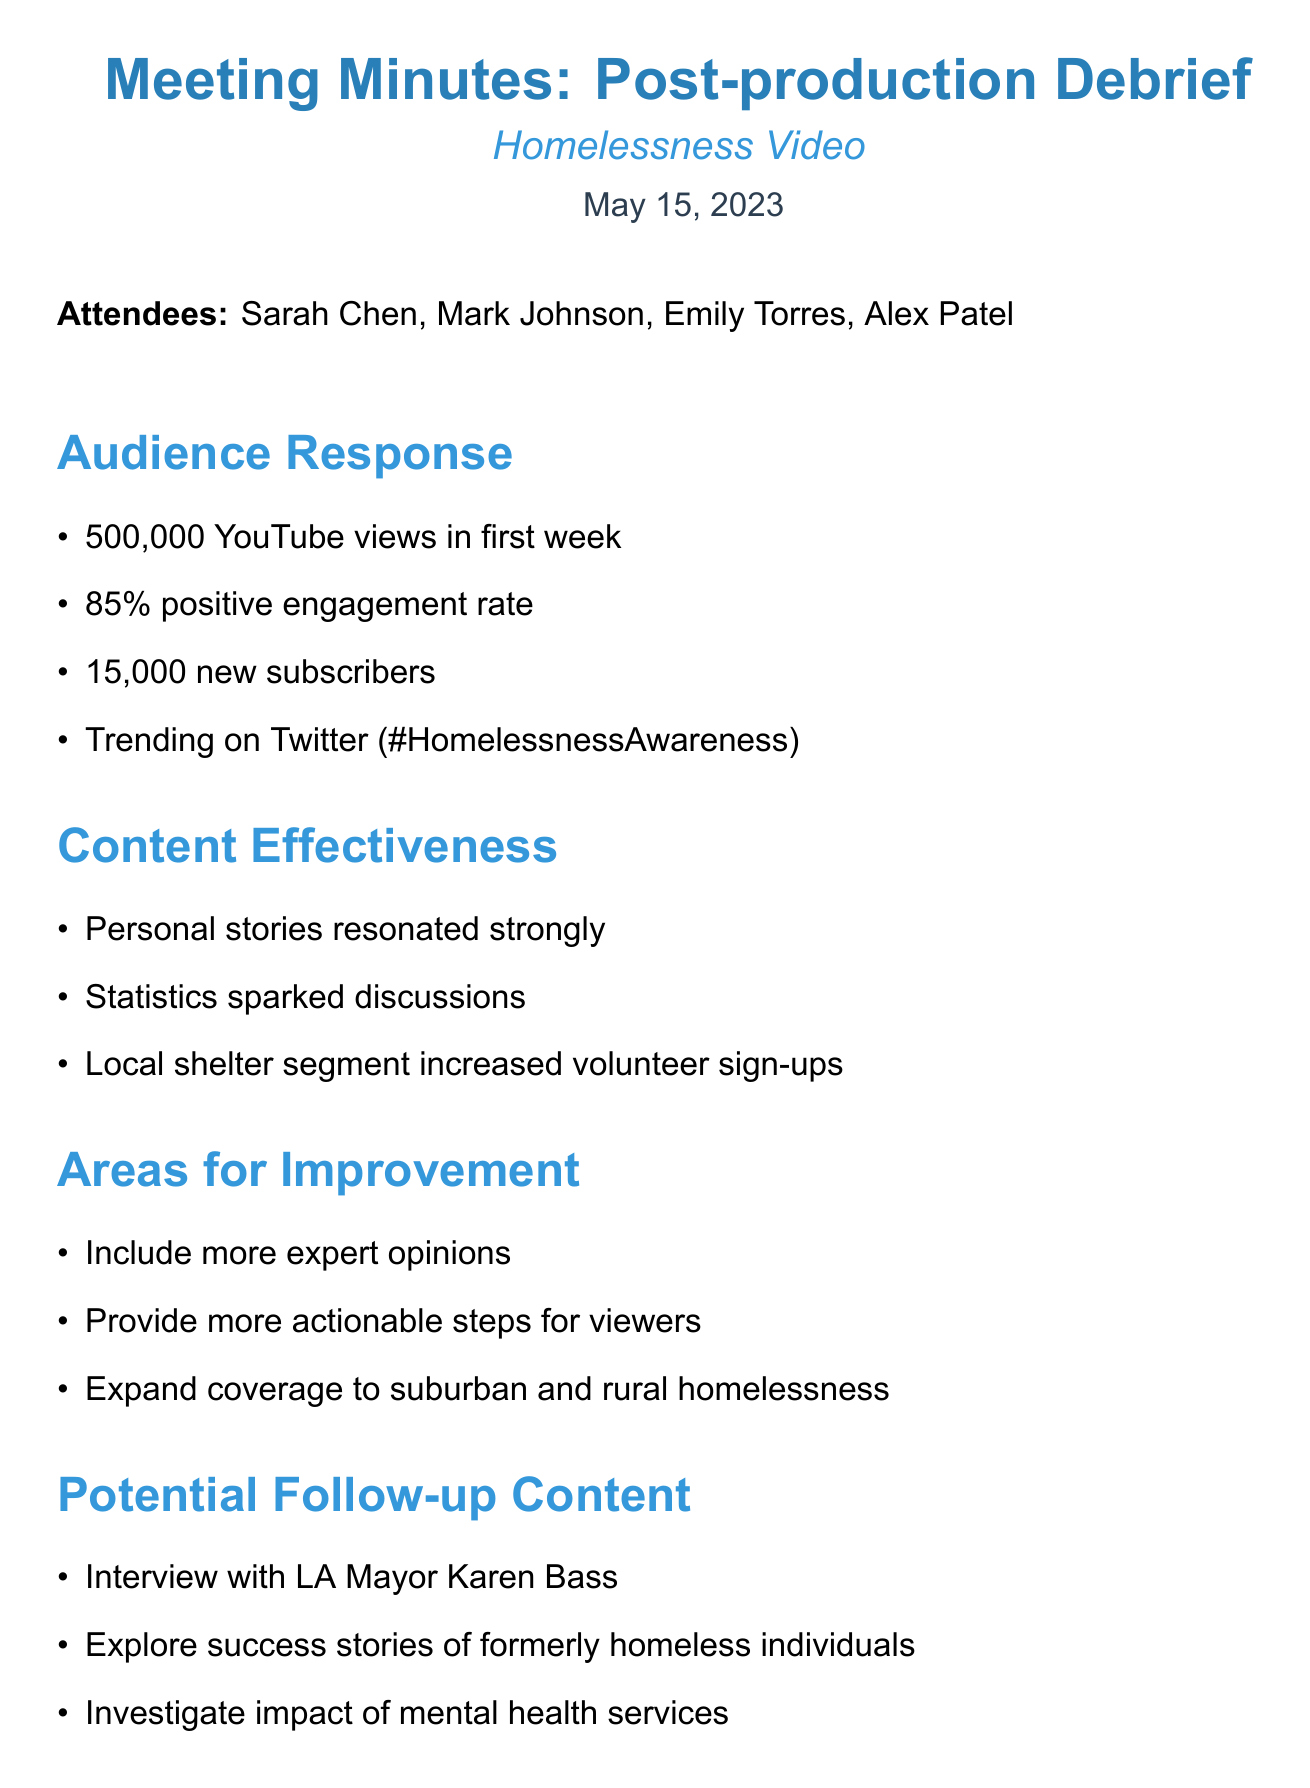What was the date of the meeting? The date of the meeting is explicitly stated in the document.
Answer: May 15, 2023 How many views did the video receive in the first week? The document provides the view count specifically for the first week after the video's release.
Answer: 500,000 What was the positive engagement rate of the video? The document mentions the engagement rate, which includes likes, shares, and comments.
Answer: 85% Who was suggested to be interviewed for follow-up content? The document lists specific individuals for potential interviews in the follow-up content section.
Answer: Karen Bass What is one area for improvement mentioned in the meeting? The document lists areas for improvement regarding the video's content.
Answer: Include more expert opinions How many new subscribers did the video gain? The document states the number of new subscribers gained due to the video.
Answer: 15,000 What type of collaboration opportunity is suggested in the meeting? The document outlines potential partner organizations for future videos.
Answer: National Alliance to End Homelessness What is one of the action items assigned to Sarah? The document details specific tasks assigned to attendees as action items.
Answer: Draft outline for follow-up video What hashtag was trending on Twitter related to the video? The document includes social media response information regarding the video.
Answer: #HomelessnessAwareness 